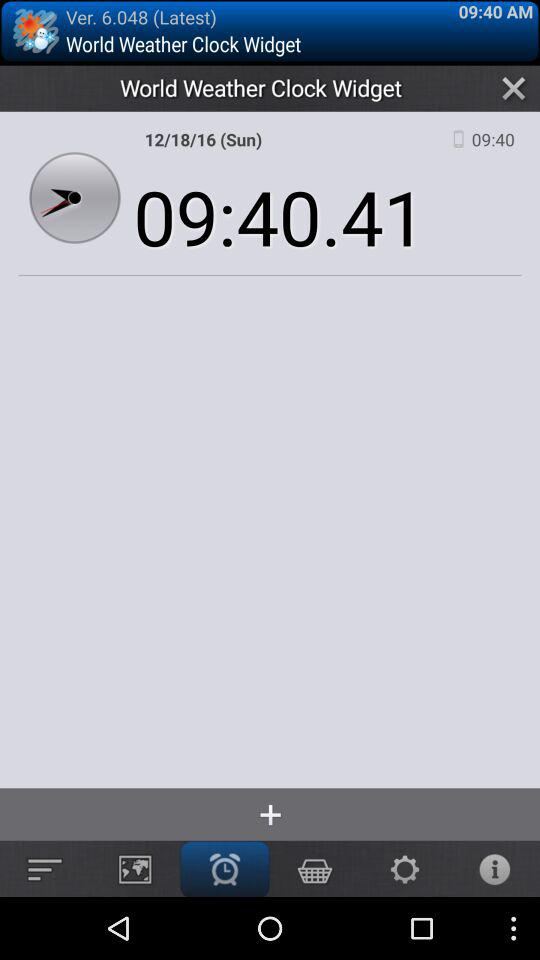What date and time are mentioned? The mentioned date and time are Sunday, December 18, 2016 and 9:40:41 respectively. 